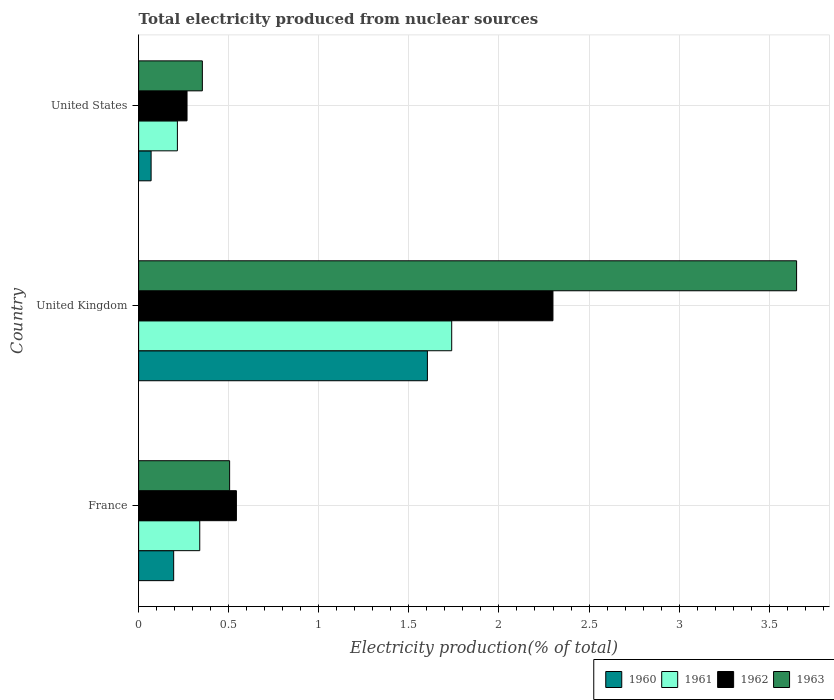How many groups of bars are there?
Give a very brief answer. 3. Are the number of bars per tick equal to the number of legend labels?
Offer a terse response. Yes. Are the number of bars on each tick of the Y-axis equal?
Offer a very short reply. Yes. How many bars are there on the 1st tick from the bottom?
Make the answer very short. 4. What is the label of the 3rd group of bars from the top?
Make the answer very short. France. What is the total electricity produced in 1961 in France?
Ensure brevity in your answer.  0.34. Across all countries, what is the maximum total electricity produced in 1961?
Ensure brevity in your answer.  1.74. Across all countries, what is the minimum total electricity produced in 1962?
Keep it short and to the point. 0.27. In which country was the total electricity produced in 1962 maximum?
Your answer should be compact. United Kingdom. What is the total total electricity produced in 1961 in the graph?
Keep it short and to the point. 2.29. What is the difference between the total electricity produced in 1960 in France and that in United States?
Keep it short and to the point. 0.13. What is the difference between the total electricity produced in 1961 in France and the total electricity produced in 1962 in United Kingdom?
Ensure brevity in your answer.  -1.96. What is the average total electricity produced in 1963 per country?
Give a very brief answer. 1.5. What is the difference between the total electricity produced in 1961 and total electricity produced in 1962 in United States?
Your response must be concise. -0.05. In how many countries, is the total electricity produced in 1960 greater than 2.2 %?
Offer a very short reply. 0. What is the ratio of the total electricity produced in 1962 in France to that in United States?
Provide a succinct answer. 2.02. Is the total electricity produced in 1963 in France less than that in United States?
Keep it short and to the point. No. Is the difference between the total electricity produced in 1961 in France and United States greater than the difference between the total electricity produced in 1962 in France and United States?
Make the answer very short. No. What is the difference between the highest and the second highest total electricity produced in 1962?
Give a very brief answer. 1.76. What is the difference between the highest and the lowest total electricity produced in 1962?
Make the answer very short. 2.03. In how many countries, is the total electricity produced in 1960 greater than the average total electricity produced in 1960 taken over all countries?
Make the answer very short. 1. Is the sum of the total electricity produced in 1960 in France and United States greater than the maximum total electricity produced in 1961 across all countries?
Provide a short and direct response. No. Is it the case that in every country, the sum of the total electricity produced in 1961 and total electricity produced in 1960 is greater than the sum of total electricity produced in 1962 and total electricity produced in 1963?
Your answer should be compact. No. What does the 1st bar from the top in United States represents?
Give a very brief answer. 1963. What does the 1st bar from the bottom in United Kingdom represents?
Provide a short and direct response. 1960. Is it the case that in every country, the sum of the total electricity produced in 1962 and total electricity produced in 1963 is greater than the total electricity produced in 1960?
Give a very brief answer. Yes. How many bars are there?
Offer a very short reply. 12. Are all the bars in the graph horizontal?
Keep it short and to the point. Yes. How many countries are there in the graph?
Keep it short and to the point. 3. What is the difference between two consecutive major ticks on the X-axis?
Keep it short and to the point. 0.5. Are the values on the major ticks of X-axis written in scientific E-notation?
Your answer should be very brief. No. Does the graph contain any zero values?
Keep it short and to the point. No. Where does the legend appear in the graph?
Provide a short and direct response. Bottom right. How many legend labels are there?
Your response must be concise. 4. What is the title of the graph?
Keep it short and to the point. Total electricity produced from nuclear sources. Does "1990" appear as one of the legend labels in the graph?
Make the answer very short. No. What is the label or title of the X-axis?
Keep it short and to the point. Electricity production(% of total). What is the label or title of the Y-axis?
Your response must be concise. Country. What is the Electricity production(% of total) in 1960 in France?
Ensure brevity in your answer.  0.19. What is the Electricity production(% of total) of 1961 in France?
Provide a succinct answer. 0.34. What is the Electricity production(% of total) of 1962 in France?
Make the answer very short. 0.54. What is the Electricity production(% of total) of 1963 in France?
Keep it short and to the point. 0.51. What is the Electricity production(% of total) in 1960 in United Kingdom?
Your answer should be very brief. 1.6. What is the Electricity production(% of total) of 1961 in United Kingdom?
Make the answer very short. 1.74. What is the Electricity production(% of total) in 1962 in United Kingdom?
Offer a very short reply. 2.3. What is the Electricity production(% of total) in 1963 in United Kingdom?
Provide a short and direct response. 3.65. What is the Electricity production(% of total) in 1960 in United States?
Give a very brief answer. 0.07. What is the Electricity production(% of total) in 1961 in United States?
Ensure brevity in your answer.  0.22. What is the Electricity production(% of total) of 1962 in United States?
Ensure brevity in your answer.  0.27. What is the Electricity production(% of total) in 1963 in United States?
Provide a succinct answer. 0.35. Across all countries, what is the maximum Electricity production(% of total) of 1960?
Make the answer very short. 1.6. Across all countries, what is the maximum Electricity production(% of total) of 1961?
Your response must be concise. 1.74. Across all countries, what is the maximum Electricity production(% of total) in 1962?
Keep it short and to the point. 2.3. Across all countries, what is the maximum Electricity production(% of total) in 1963?
Give a very brief answer. 3.65. Across all countries, what is the minimum Electricity production(% of total) of 1960?
Give a very brief answer. 0.07. Across all countries, what is the minimum Electricity production(% of total) in 1961?
Provide a succinct answer. 0.22. Across all countries, what is the minimum Electricity production(% of total) of 1962?
Provide a succinct answer. 0.27. Across all countries, what is the minimum Electricity production(% of total) in 1963?
Your answer should be very brief. 0.35. What is the total Electricity production(% of total) in 1960 in the graph?
Provide a short and direct response. 1.87. What is the total Electricity production(% of total) in 1961 in the graph?
Your answer should be very brief. 2.29. What is the total Electricity production(% of total) in 1962 in the graph?
Your answer should be very brief. 3.11. What is the total Electricity production(% of total) in 1963 in the graph?
Offer a terse response. 4.51. What is the difference between the Electricity production(% of total) of 1960 in France and that in United Kingdom?
Provide a succinct answer. -1.41. What is the difference between the Electricity production(% of total) of 1961 in France and that in United Kingdom?
Provide a succinct answer. -1.4. What is the difference between the Electricity production(% of total) in 1962 in France and that in United Kingdom?
Ensure brevity in your answer.  -1.76. What is the difference between the Electricity production(% of total) of 1963 in France and that in United Kingdom?
Give a very brief answer. -3.15. What is the difference between the Electricity production(% of total) in 1960 in France and that in United States?
Provide a succinct answer. 0.13. What is the difference between the Electricity production(% of total) in 1961 in France and that in United States?
Offer a terse response. 0.12. What is the difference between the Electricity production(% of total) in 1962 in France and that in United States?
Offer a very short reply. 0.27. What is the difference between the Electricity production(% of total) of 1963 in France and that in United States?
Offer a terse response. 0.15. What is the difference between the Electricity production(% of total) of 1960 in United Kingdom and that in United States?
Your answer should be very brief. 1.53. What is the difference between the Electricity production(% of total) of 1961 in United Kingdom and that in United States?
Give a very brief answer. 1.52. What is the difference between the Electricity production(% of total) in 1962 in United Kingdom and that in United States?
Ensure brevity in your answer.  2.03. What is the difference between the Electricity production(% of total) in 1963 in United Kingdom and that in United States?
Keep it short and to the point. 3.3. What is the difference between the Electricity production(% of total) of 1960 in France and the Electricity production(% of total) of 1961 in United Kingdom?
Provide a short and direct response. -1.54. What is the difference between the Electricity production(% of total) in 1960 in France and the Electricity production(% of total) in 1962 in United Kingdom?
Offer a terse response. -2.11. What is the difference between the Electricity production(% of total) of 1960 in France and the Electricity production(% of total) of 1963 in United Kingdom?
Ensure brevity in your answer.  -3.46. What is the difference between the Electricity production(% of total) of 1961 in France and the Electricity production(% of total) of 1962 in United Kingdom?
Offer a very short reply. -1.96. What is the difference between the Electricity production(% of total) of 1961 in France and the Electricity production(% of total) of 1963 in United Kingdom?
Make the answer very short. -3.31. What is the difference between the Electricity production(% of total) in 1962 in France and the Electricity production(% of total) in 1963 in United Kingdom?
Your answer should be very brief. -3.11. What is the difference between the Electricity production(% of total) in 1960 in France and the Electricity production(% of total) in 1961 in United States?
Your answer should be very brief. -0.02. What is the difference between the Electricity production(% of total) of 1960 in France and the Electricity production(% of total) of 1962 in United States?
Keep it short and to the point. -0.07. What is the difference between the Electricity production(% of total) of 1960 in France and the Electricity production(% of total) of 1963 in United States?
Your response must be concise. -0.16. What is the difference between the Electricity production(% of total) of 1961 in France and the Electricity production(% of total) of 1962 in United States?
Your response must be concise. 0.07. What is the difference between the Electricity production(% of total) of 1961 in France and the Electricity production(% of total) of 1963 in United States?
Your answer should be compact. -0.01. What is the difference between the Electricity production(% of total) of 1962 in France and the Electricity production(% of total) of 1963 in United States?
Your answer should be compact. 0.19. What is the difference between the Electricity production(% of total) of 1960 in United Kingdom and the Electricity production(% of total) of 1961 in United States?
Provide a short and direct response. 1.39. What is the difference between the Electricity production(% of total) of 1960 in United Kingdom and the Electricity production(% of total) of 1962 in United States?
Your answer should be compact. 1.33. What is the difference between the Electricity production(% of total) of 1960 in United Kingdom and the Electricity production(% of total) of 1963 in United States?
Your answer should be very brief. 1.25. What is the difference between the Electricity production(% of total) in 1961 in United Kingdom and the Electricity production(% of total) in 1962 in United States?
Offer a very short reply. 1.47. What is the difference between the Electricity production(% of total) of 1961 in United Kingdom and the Electricity production(% of total) of 1963 in United States?
Ensure brevity in your answer.  1.38. What is the difference between the Electricity production(% of total) in 1962 in United Kingdom and the Electricity production(% of total) in 1963 in United States?
Your response must be concise. 1.95. What is the average Electricity production(% of total) of 1960 per country?
Your answer should be very brief. 0.62. What is the average Electricity production(% of total) in 1961 per country?
Provide a short and direct response. 0.76. What is the average Electricity production(% of total) in 1962 per country?
Your response must be concise. 1.04. What is the average Electricity production(% of total) in 1963 per country?
Make the answer very short. 1.5. What is the difference between the Electricity production(% of total) of 1960 and Electricity production(% of total) of 1961 in France?
Provide a short and direct response. -0.14. What is the difference between the Electricity production(% of total) of 1960 and Electricity production(% of total) of 1962 in France?
Ensure brevity in your answer.  -0.35. What is the difference between the Electricity production(% of total) of 1960 and Electricity production(% of total) of 1963 in France?
Your answer should be compact. -0.31. What is the difference between the Electricity production(% of total) of 1961 and Electricity production(% of total) of 1962 in France?
Give a very brief answer. -0.2. What is the difference between the Electricity production(% of total) in 1961 and Electricity production(% of total) in 1963 in France?
Give a very brief answer. -0.17. What is the difference between the Electricity production(% of total) of 1962 and Electricity production(% of total) of 1963 in France?
Provide a succinct answer. 0.04. What is the difference between the Electricity production(% of total) in 1960 and Electricity production(% of total) in 1961 in United Kingdom?
Offer a terse response. -0.13. What is the difference between the Electricity production(% of total) of 1960 and Electricity production(% of total) of 1962 in United Kingdom?
Offer a very short reply. -0.7. What is the difference between the Electricity production(% of total) in 1960 and Electricity production(% of total) in 1963 in United Kingdom?
Give a very brief answer. -2.05. What is the difference between the Electricity production(% of total) in 1961 and Electricity production(% of total) in 1962 in United Kingdom?
Your response must be concise. -0.56. What is the difference between the Electricity production(% of total) of 1961 and Electricity production(% of total) of 1963 in United Kingdom?
Provide a short and direct response. -1.91. What is the difference between the Electricity production(% of total) of 1962 and Electricity production(% of total) of 1963 in United Kingdom?
Your answer should be very brief. -1.35. What is the difference between the Electricity production(% of total) in 1960 and Electricity production(% of total) in 1961 in United States?
Provide a short and direct response. -0.15. What is the difference between the Electricity production(% of total) of 1960 and Electricity production(% of total) of 1962 in United States?
Your response must be concise. -0.2. What is the difference between the Electricity production(% of total) of 1960 and Electricity production(% of total) of 1963 in United States?
Provide a short and direct response. -0.28. What is the difference between the Electricity production(% of total) of 1961 and Electricity production(% of total) of 1962 in United States?
Provide a succinct answer. -0.05. What is the difference between the Electricity production(% of total) of 1961 and Electricity production(% of total) of 1963 in United States?
Ensure brevity in your answer.  -0.14. What is the difference between the Electricity production(% of total) in 1962 and Electricity production(% of total) in 1963 in United States?
Ensure brevity in your answer.  -0.09. What is the ratio of the Electricity production(% of total) in 1960 in France to that in United Kingdom?
Provide a succinct answer. 0.12. What is the ratio of the Electricity production(% of total) of 1961 in France to that in United Kingdom?
Your response must be concise. 0.2. What is the ratio of the Electricity production(% of total) in 1962 in France to that in United Kingdom?
Give a very brief answer. 0.24. What is the ratio of the Electricity production(% of total) of 1963 in France to that in United Kingdom?
Make the answer very short. 0.14. What is the ratio of the Electricity production(% of total) in 1960 in France to that in United States?
Keep it short and to the point. 2.81. What is the ratio of the Electricity production(% of total) of 1961 in France to that in United States?
Your answer should be compact. 1.58. What is the ratio of the Electricity production(% of total) of 1962 in France to that in United States?
Provide a succinct answer. 2.02. What is the ratio of the Electricity production(% of total) in 1963 in France to that in United States?
Make the answer very short. 1.43. What is the ratio of the Electricity production(% of total) in 1960 in United Kingdom to that in United States?
Make the answer very short. 23.14. What is the ratio of the Electricity production(% of total) of 1961 in United Kingdom to that in United States?
Your answer should be compact. 8.08. What is the ratio of the Electricity production(% of total) in 1962 in United Kingdom to that in United States?
Your answer should be compact. 8.56. What is the ratio of the Electricity production(% of total) of 1963 in United Kingdom to that in United States?
Give a very brief answer. 10.32. What is the difference between the highest and the second highest Electricity production(% of total) of 1960?
Give a very brief answer. 1.41. What is the difference between the highest and the second highest Electricity production(% of total) in 1961?
Keep it short and to the point. 1.4. What is the difference between the highest and the second highest Electricity production(% of total) in 1962?
Ensure brevity in your answer.  1.76. What is the difference between the highest and the second highest Electricity production(% of total) in 1963?
Your answer should be compact. 3.15. What is the difference between the highest and the lowest Electricity production(% of total) of 1960?
Your answer should be very brief. 1.53. What is the difference between the highest and the lowest Electricity production(% of total) of 1961?
Your response must be concise. 1.52. What is the difference between the highest and the lowest Electricity production(% of total) in 1962?
Your answer should be compact. 2.03. What is the difference between the highest and the lowest Electricity production(% of total) of 1963?
Provide a short and direct response. 3.3. 